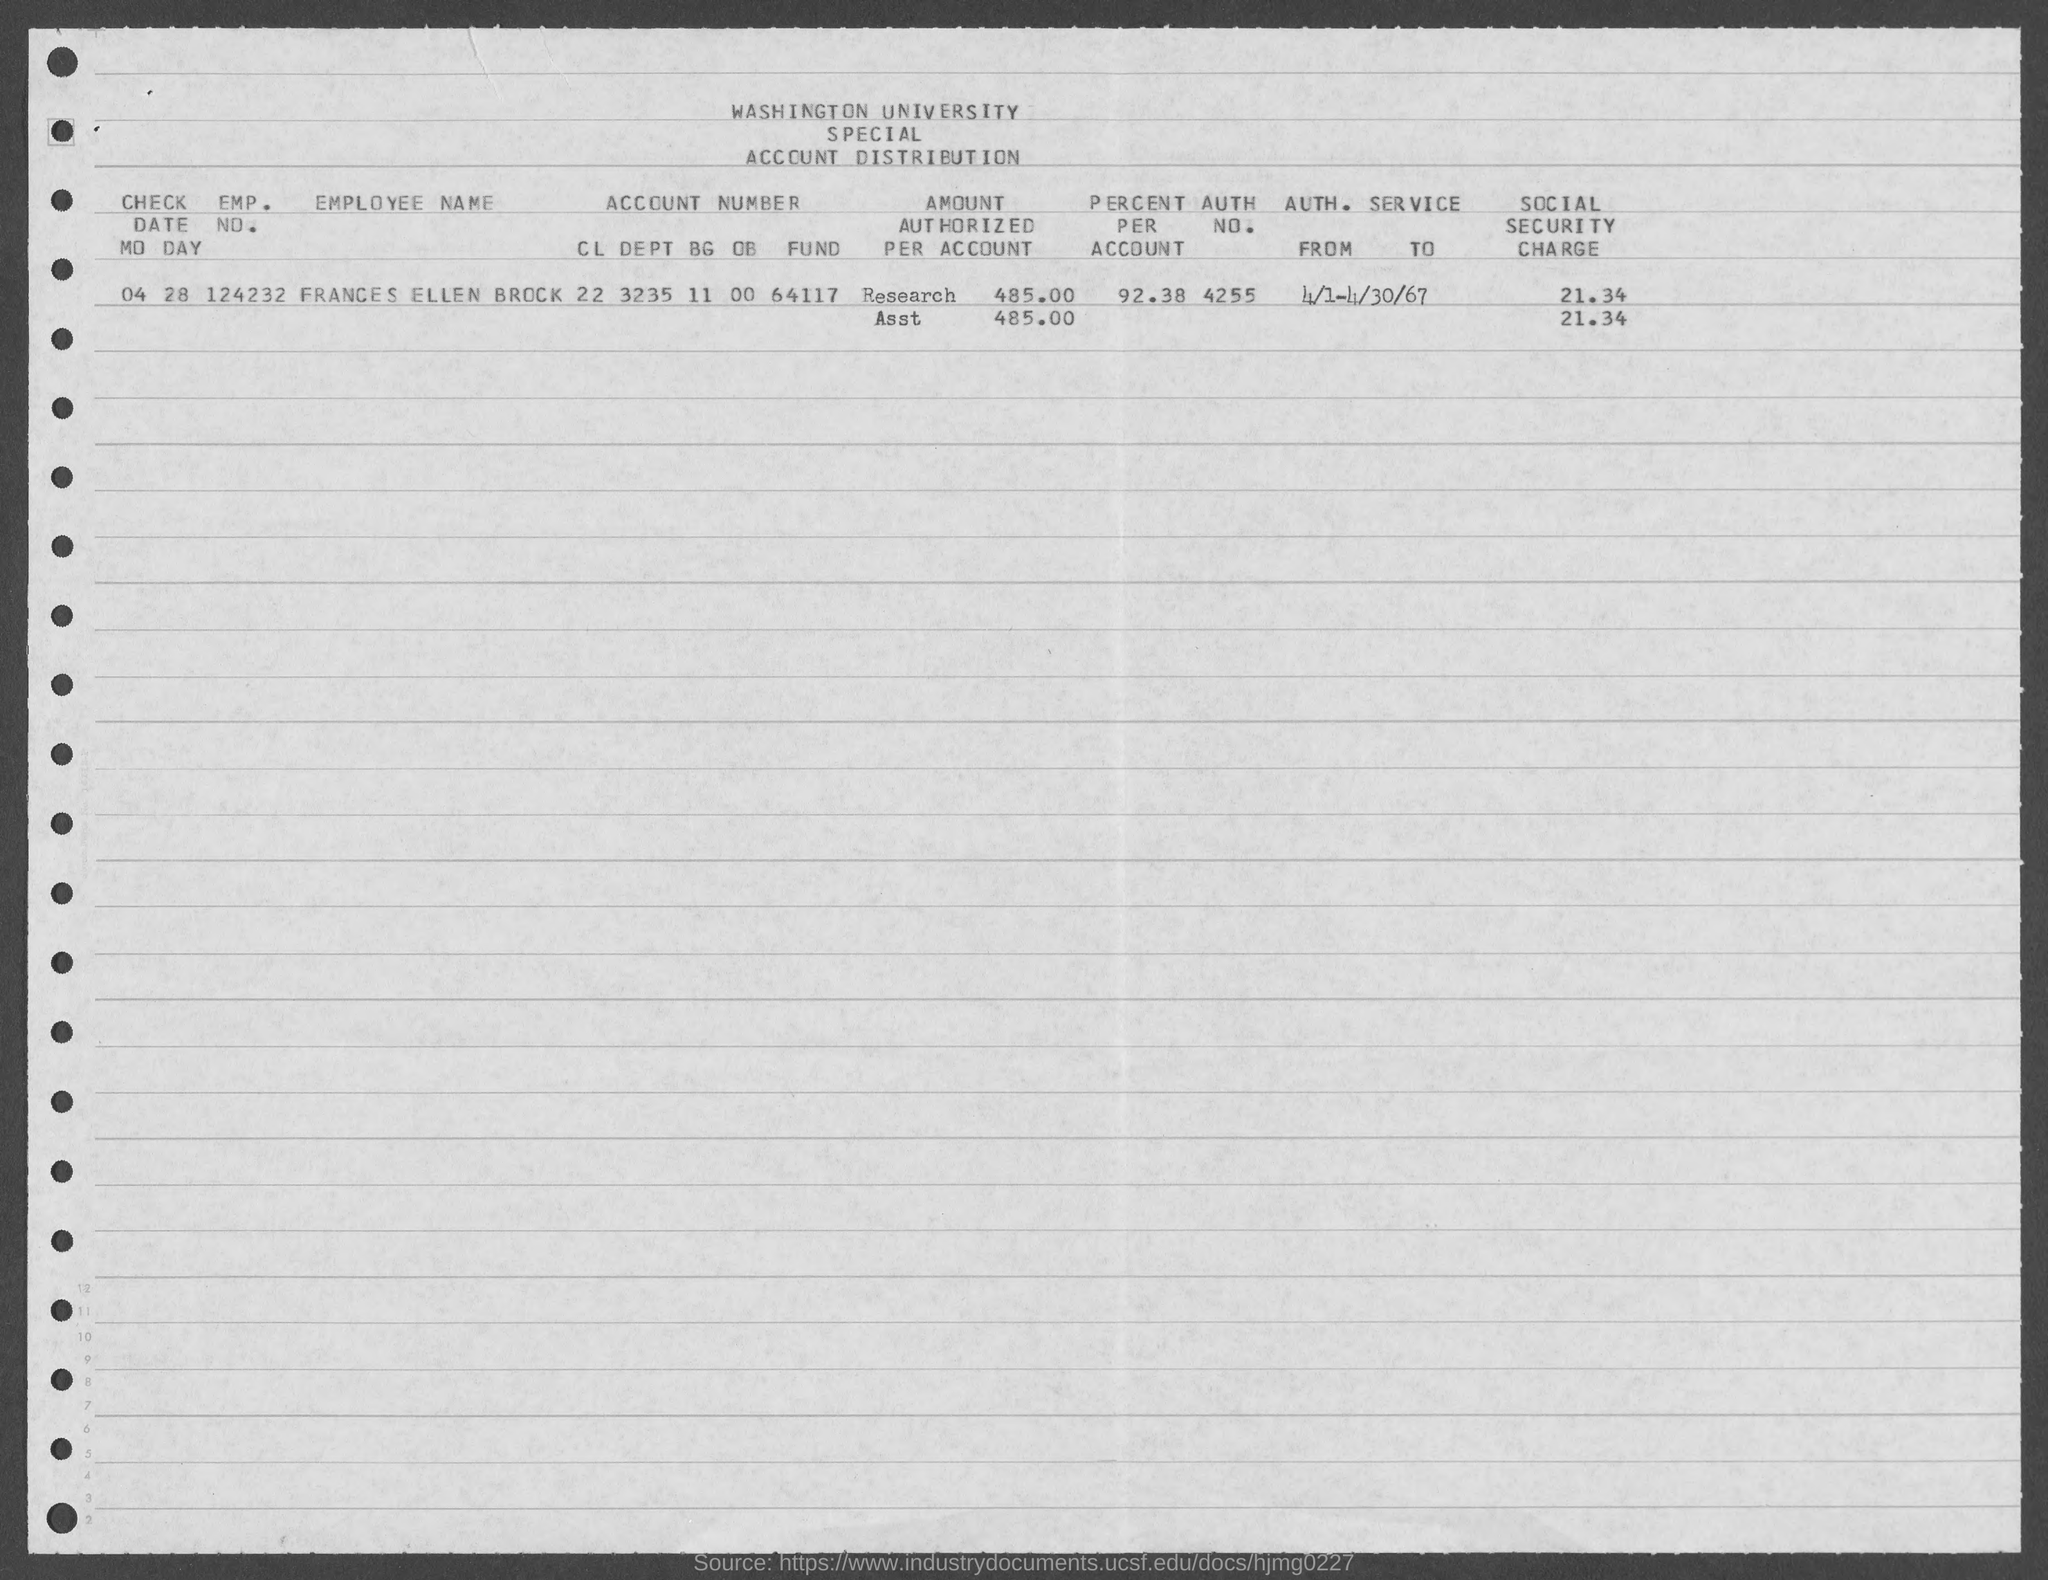Mention a couple of crucial points in this snapshot. The value of the social security charge mentioned in the given page is 21.34%. The check date mentioned in the given form is 04 28. The value of the percentage mentioned in the given form is 92.38%. The authorization number mentioned in the given form is 4255. The employment number of Frances Ellen Brock as mentioned in the given form is 124232... 